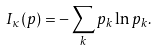Convert formula to latex. <formula><loc_0><loc_0><loc_500><loc_500>I _ { \kappa } ( p ) = - \sum _ { k } p _ { k } \ln p _ { k } .</formula> 